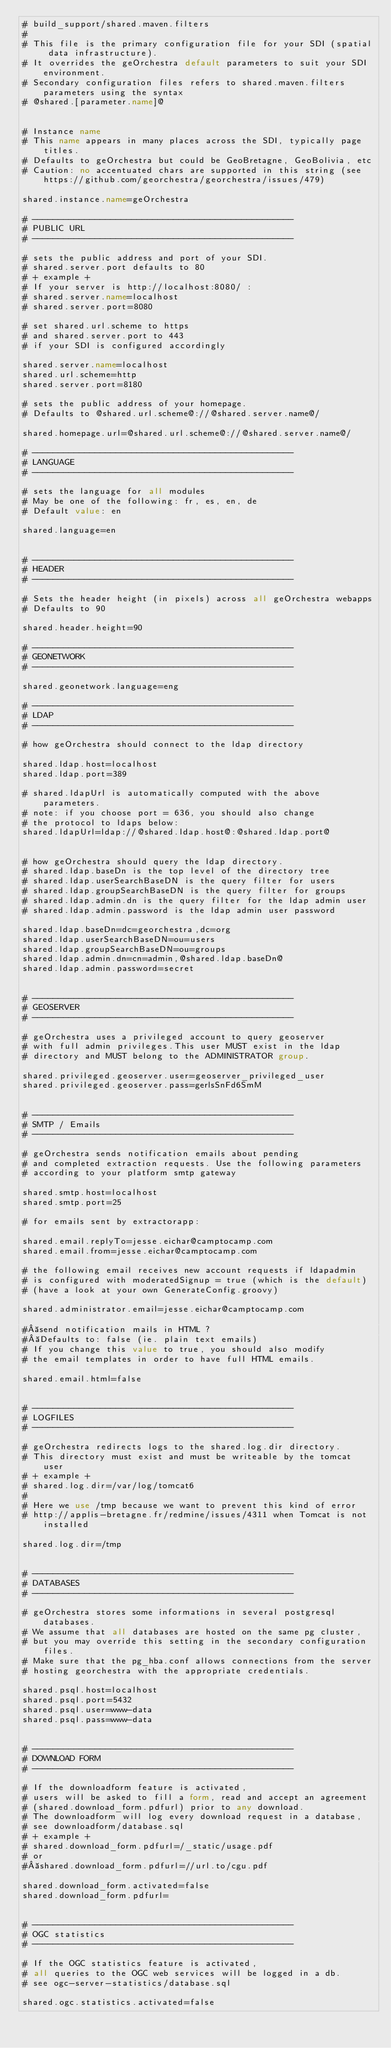<code> <loc_0><loc_0><loc_500><loc_500><_XML_># build_support/shared.maven.filters
#
# This file is the primary configuration file for your SDI (spatial data infrastructure).
# It overrides the geOrchestra default parameters to suit your SDI environment.
# Secondary configuration files refers to shared.maven.filters parameters using the syntax
# @shared.[parameter.name]@


# Instance name
# This name appears in many places across the SDI, typically page titles.
# Defaults to geOrchestra but could be GeoBretagne, GeoBolivia, etc
# Caution: no accentuated chars are supported in this string (see https://github.com/georchestra/georchestra/issues/479)

shared.instance.name=geOrchestra

# --------------------------------------------------
# PUBLIC URL
# --------------------------------------------------

# sets the public address and port of your SDI.
# shared.server.port defaults to 80
# + example +
# If your server is http://localhost:8080/ :
# shared.server.name=localhost
# shared.server.port=8080

# set shared.url.scheme to https 
# and shared.server.port to 443
# if your SDI is configured accordingly

shared.server.name=localhost
shared.url.scheme=http
shared.server.port=8180

# sets the public address of your homepage.
# Defaults to @shared.url.scheme@://@shared.server.name@/

shared.homepage.url=@shared.url.scheme@://@shared.server.name@/

# --------------------------------------------------
# LANGUAGE
# --------------------------------------------------

# sets the language for all modules
# May be one of the following: fr, es, en, de
# Default value: en

shared.language=en


# --------------------------------------------------
# HEADER
# --------------------------------------------------

# Sets the header height (in pixels) across all geOrchestra webapps
# Defaults to 90

shared.header.height=90

# --------------------------------------------------
# GEONETWORK
# --------------------------------------------------

shared.geonetwork.language=eng

# --------------------------------------------------
# LDAP
# --------------------------------------------------

# how geOrchestra should connect to the ldap directory

shared.ldap.host=localhost
shared.ldap.port=389

# shared.ldapUrl is automatically computed with the above parameters.
# note: if you choose port = 636, you should also change 
# the protocol to ldaps below:
shared.ldapUrl=ldap://@shared.ldap.host@:@shared.ldap.port@


# how geOrchestra should query the ldap directory.
# shared.ldap.baseDn is the top level of the directory tree
# shared.ldap.userSearchBaseDN is the query filter for users
# shared.ldap.groupSearchBaseDN is the query filter for groups
# shared.ldap.admin.dn is the query filter for the ldap admin user
# shared.ldap.admin.password is the ldap admin user password

shared.ldap.baseDn=dc=georchestra,dc=org
shared.ldap.userSearchBaseDN=ou=users
shared.ldap.groupSearchBaseDN=ou=groups
shared.ldap.admin.dn=cn=admin,@shared.ldap.baseDn@
shared.ldap.admin.password=secret


# --------------------------------------------------
# GEOSERVER
# --------------------------------------------------

# geOrchestra uses a privileged account to query geoserver
# with full admin privileges.This user MUST exist in the ldap
# directory and MUST belong to the ADMINISTRATOR group.

shared.privileged.geoserver.user=geoserver_privileged_user
shared.privileged.geoserver.pass=gerlsSnFd6SmM


# --------------------------------------------------
# SMTP / Emails
# --------------------------------------------------

# geOrchestra sends notification emails about pending
# and completed extraction requests. Use the following parameters
# according to your platform smtp gateway

shared.smtp.host=localhost
shared.smtp.port=25

# for emails sent by extractorapp:

shared.email.replyTo=jesse.eichar@camptocamp.com
shared.email.from=jesse.eichar@camptocamp.com

# the following email receives new account requests if ldapadmin
# is configured with moderatedSignup = true (which is the default)
# (have a look at your own GenerateConfig.groovy)

shared.administrator.email=jesse.eichar@camptocamp.com

# send notification mails in HTML ?
# Defaults to: false (ie. plain text emails)
# If you change this value to true, you should also modify 
# the email templates in order to have full HTML emails.

shared.email.html=false


# --------------------------------------------------
# LOGFILES
# --------------------------------------------------

# geOrchestra redirects logs to the shared.log.dir directory.
# This directory must exist and must be writeable by the tomcat user
# + example +
# shared.log.dir=/var/log/tomcat6
#
# Here we use /tmp because we want to prevent this kind of error 
# http://applis-bretagne.fr/redmine/issues/4311 when Tomcat is not installed

shared.log.dir=/tmp


# --------------------------------------------------
# DATABASES
# --------------------------------------------------

# geOrchestra stores some informations in several postgresql databases.
# We assume that all databases are hosted on the same pg cluster,
# but you may override this setting in the secondary configuration files.
# Make sure that the pg_hba.conf allows connections from the server
# hosting georchestra with the appropriate credentials.

shared.psql.host=localhost
shared.psql.port=5432
shared.psql.user=www-data
shared.psql.pass=www-data


# --------------------------------------------------
# DOWNLOAD FORM
# --------------------------------------------------

# If the downloadform feature is activated,
# users will be asked to fill a form, read and accept an agreement
# (shared.download_form.pdfurl) prior to any download.
# The downloadform will log every download request in a database,
# see downloadform/database.sql
# + example +
# shared.download_form.pdfurl=/_static/usage.pdf
# or
# shared.download_form.pdfurl=//url.to/cgu.pdf

shared.download_form.activated=false
shared.download_form.pdfurl=


# --------------------------------------------------
# OGC statistics
# --------------------------------------------------

# If the OGC statistics feature is activated,
# all queries to the OGC web services will be logged in a db.
# see ogc-server-statistics/database.sql

shared.ogc.statistics.activated=false


</code> 